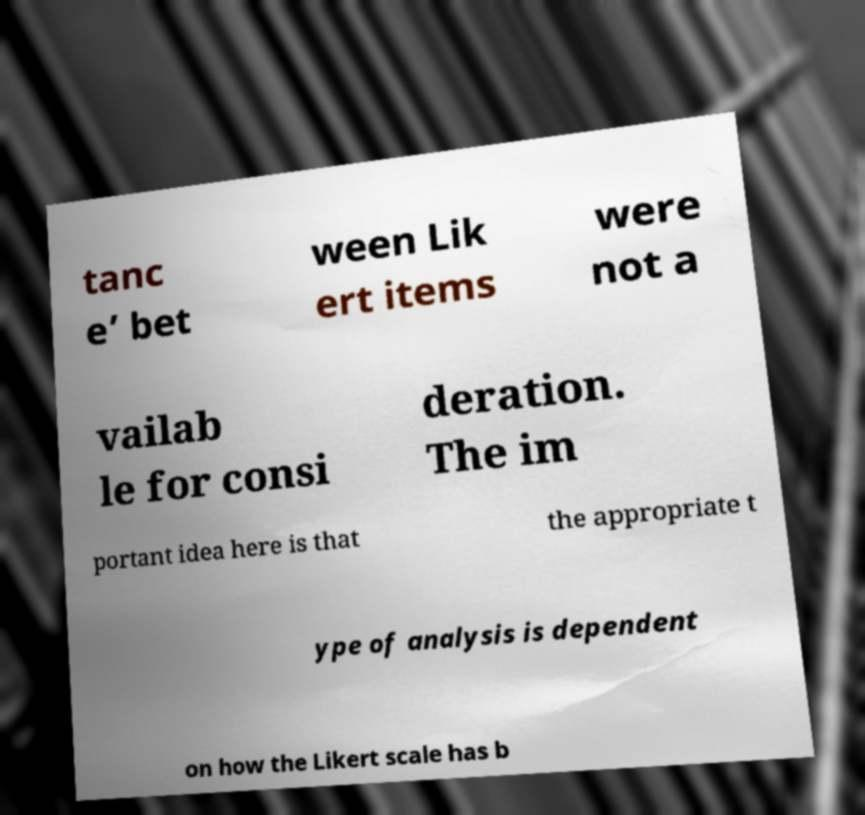For documentation purposes, I need the text within this image transcribed. Could you provide that? tanc e’ bet ween Lik ert items were not a vailab le for consi deration. The im portant idea here is that the appropriate t ype of analysis is dependent on how the Likert scale has b 